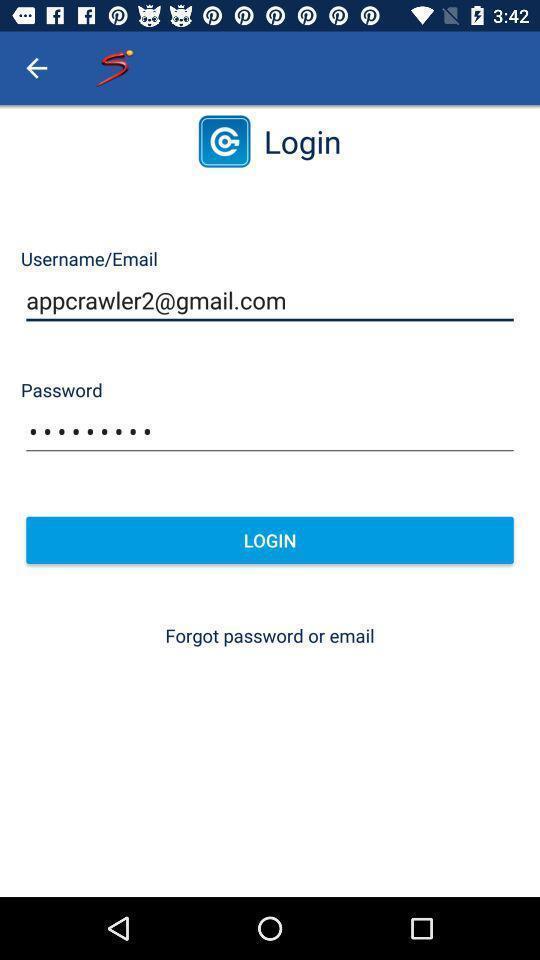Tell me about the visual elements in this screen capture. Page showing login page. 